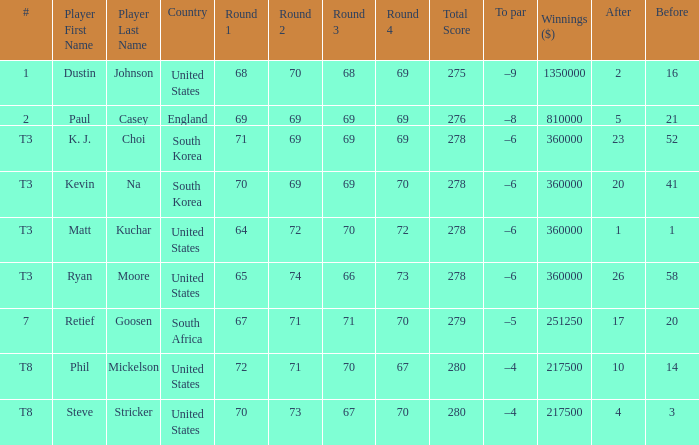What is the # listed when the score is 70-69-69-70=278? T3. 